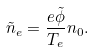<formula> <loc_0><loc_0><loc_500><loc_500>\tilde { n } _ { e } = \frac { e \tilde { \phi } } { T _ { e } } n _ { 0 } .</formula> 